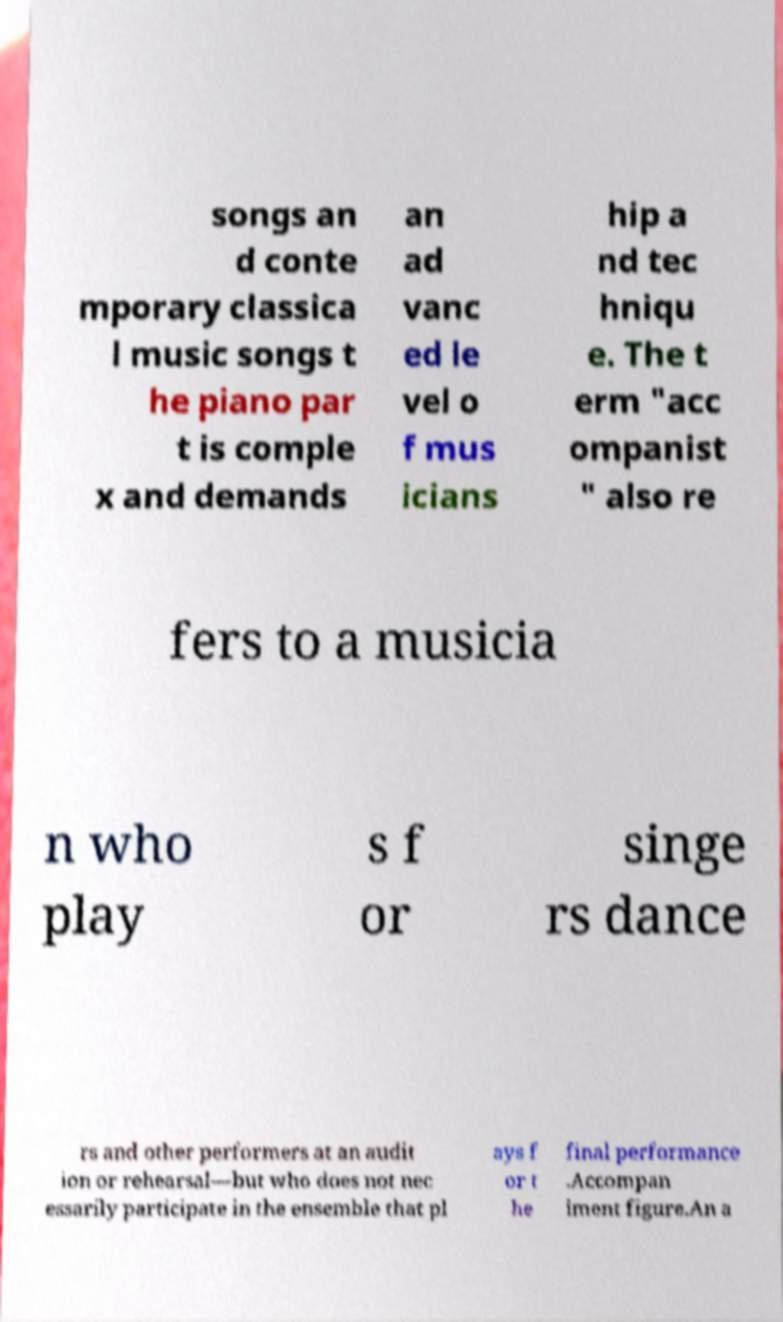There's text embedded in this image that I need extracted. Can you transcribe it verbatim? songs an d conte mporary classica l music songs t he piano par t is comple x and demands an ad vanc ed le vel o f mus icians hip a nd tec hniqu e. The t erm "acc ompanist " also re fers to a musicia n who play s f or singe rs dance rs and other performers at an audit ion or rehearsal—but who does not nec essarily participate in the ensemble that pl ays f or t he final performance .Accompan iment figure.An a 